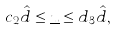<formula> <loc_0><loc_0><loc_500><loc_500>c _ { 2 } \hat { d } \leq \underline { u } \leq d _ { 3 } \hat { d } ,</formula> 